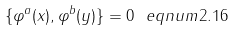Convert formula to latex. <formula><loc_0><loc_0><loc_500><loc_500>\{ \varphi ^ { a } ( x ) , \varphi ^ { b } ( y ) \} = 0 \ e q n u m { 2 . 1 6 }</formula> 